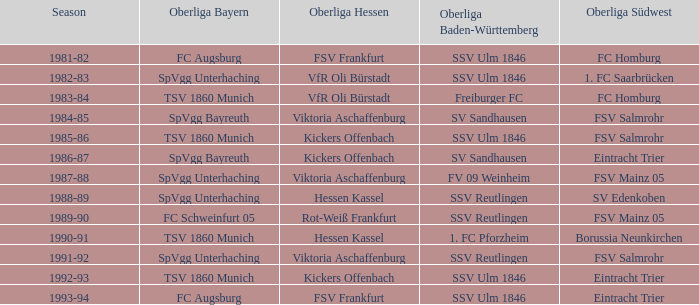Which oberliga baden-württemberg includes a 1991-92 term? SSV Reutlingen. 